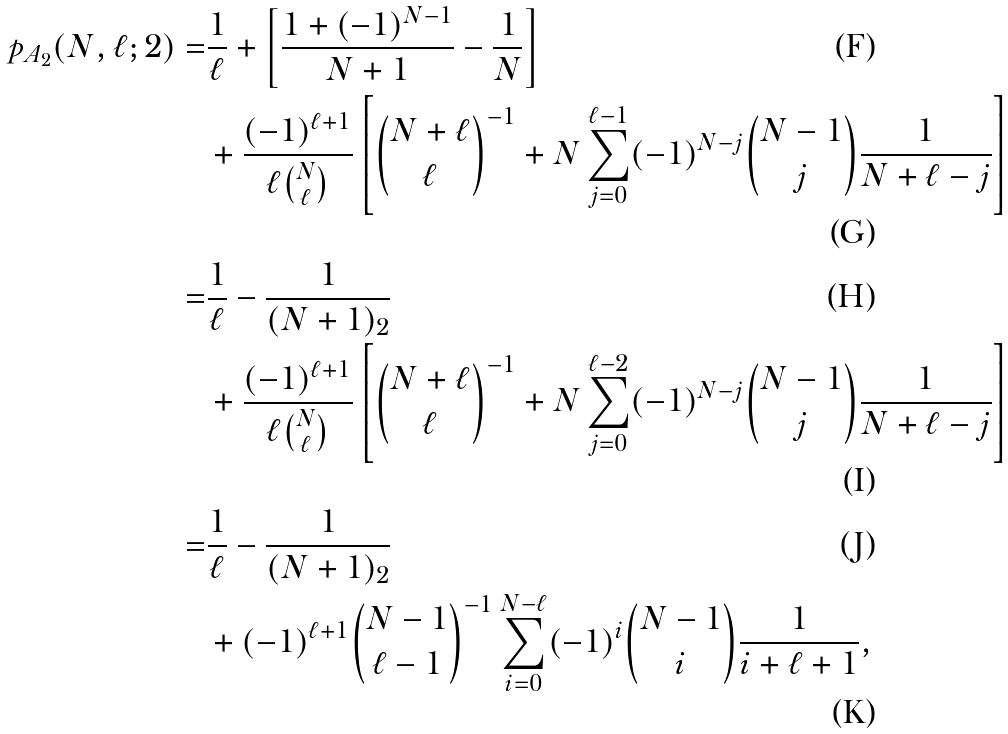<formula> <loc_0><loc_0><loc_500><loc_500>p _ { A _ { 2 } } ( N , \ell ; 2 ) = & \frac { 1 } { \ell } + \left [ \frac { 1 + ( - 1 ) ^ { N - 1 } } { N + 1 } - \frac { 1 } { N } \right ] \\ & + \frac { ( - 1 ) ^ { \ell + 1 } } { \ell \binom { N } { \ell } } \left [ \binom { N + \ell } { \ell } ^ { - 1 } + N \sum _ { j = 0 } ^ { \ell - 1 } ( - 1 ) ^ { N - j } \binom { N - 1 } { j } \frac { 1 } { N + \ell - j } \right ] \\ = & \frac { 1 } { \ell } - \frac { 1 } { ( N + 1 ) _ { 2 } } \\ & + \frac { ( - 1 ) ^ { \ell + 1 } } { \ell \binom { N } { \ell } } \left [ \binom { N + \ell } { \ell } ^ { - 1 } + N \sum _ { j = 0 } ^ { \ell - 2 } ( - 1 ) ^ { N - j } \binom { N - 1 } { j } \frac { 1 } { N + \ell - j } \right ] \\ = & \frac { 1 } { \ell } - \frac { 1 } { ( N + 1 ) _ { 2 } } \\ & + ( - 1 ) ^ { \ell + 1 } \binom { N - 1 } { \ell - 1 } ^ { - 1 } \sum _ { i = 0 } ^ { N - \ell } ( - 1 ) ^ { i } \binom { N - 1 } { i } \frac { 1 } { i + \ell + 1 } ,</formula> 